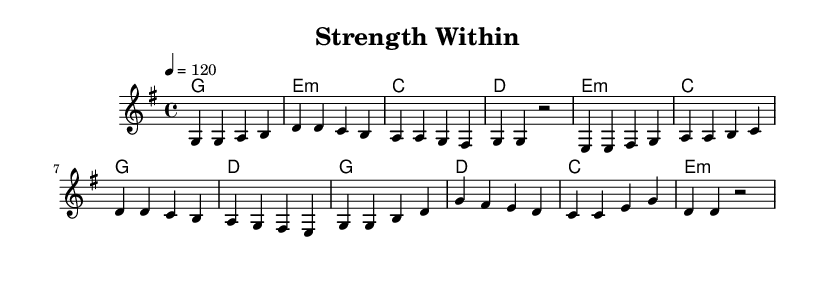What is the key signature of this music? The key signature is G major, which has one sharp (F#). This can be identified from the key signature indicated at the beginning of the sheet music.
Answer: G major What is the time signature of this music? The time signature is 4/4, which means there are four beats per measure and the quarter note gets one beat. This is evident from the time signature notation seen in the sheet music.
Answer: 4/4 What is the tempo of this music? The tempo is 120 beats per minute, indicated by the tempo marking that shows "4 = 120" at the beginning.
Answer: 120 What chord follows the 'g' note in the verse? The chord that follows is E minor, which is indicated in the harmony section aligned with the melody notes. After the 'g' note, the first chord displayed is E minor.
Answer: E minor How many measures are there in the chorus? There are four measures in the chorus, as counted from the notation provided in the sheet music under the chorus section.
Answer: Four measures What is the last note in the melody? The last note in the melody is D, as shown at the end of the melody part in the score. The final note is indicated right before the rest symbol.
Answer: D What is a typical theme of the lyrics suggested by this sheet music? The theme suggested is personal growth and overcoming challenges, which is common in uplifting K-Pop songs. This inference is drawn from the title "Strength Within" and the overall uplifting nature of the melody.
Answer: Personal growth 